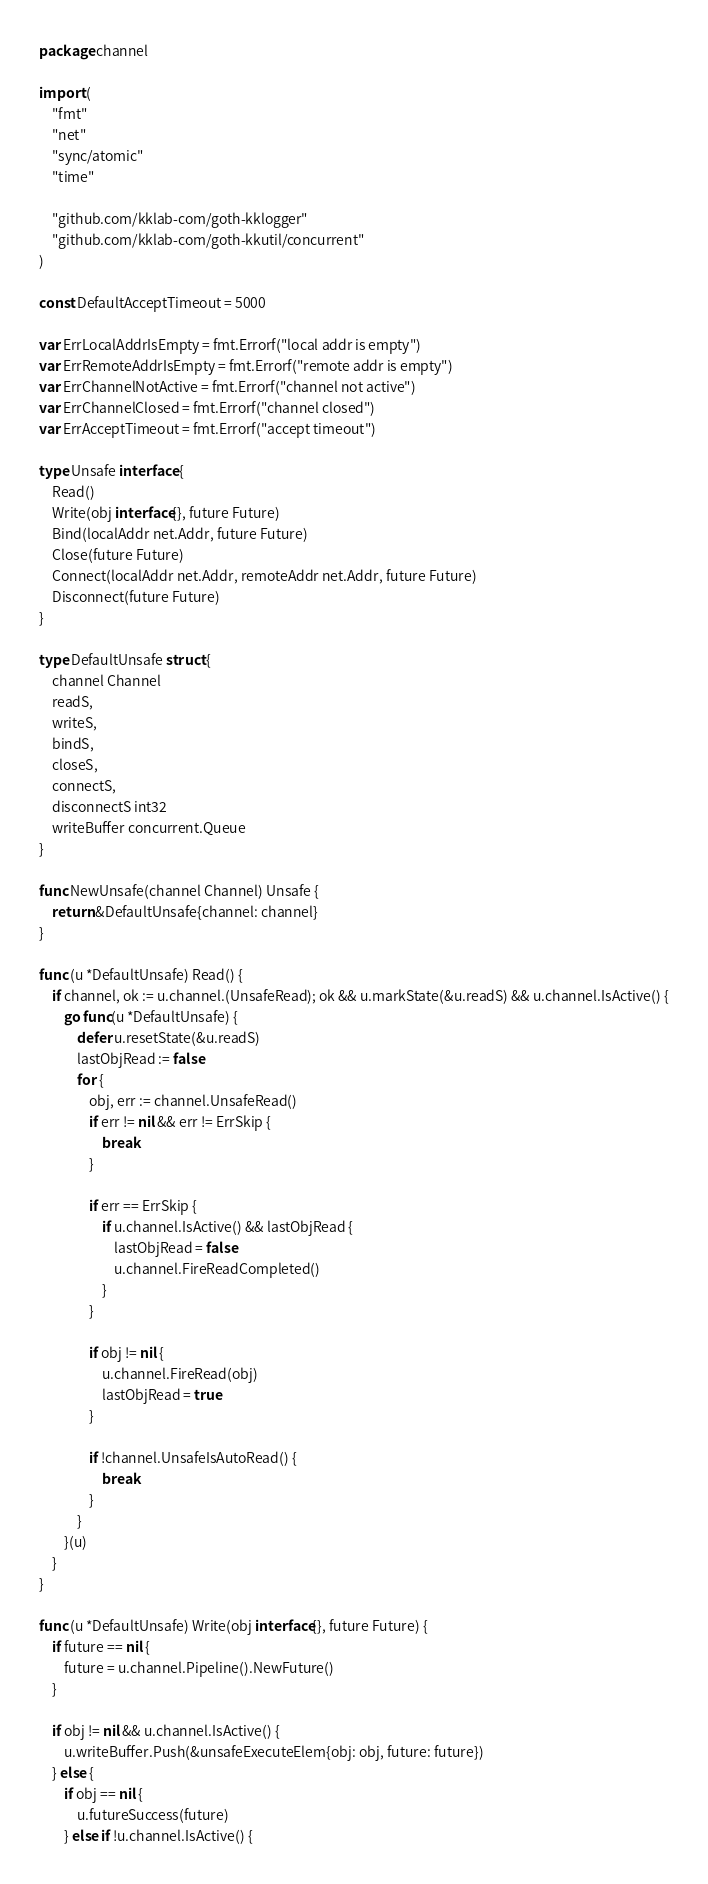<code> <loc_0><loc_0><loc_500><loc_500><_Go_>package channel

import (
	"fmt"
	"net"
	"sync/atomic"
	"time"

	"github.com/kklab-com/goth-kklogger"
	"github.com/kklab-com/goth-kkutil/concurrent"
)

const DefaultAcceptTimeout = 5000

var ErrLocalAddrIsEmpty = fmt.Errorf("local addr is empty")
var ErrRemoteAddrIsEmpty = fmt.Errorf("remote addr is empty")
var ErrChannelNotActive = fmt.Errorf("channel not active")
var ErrChannelClosed = fmt.Errorf("channel closed")
var ErrAcceptTimeout = fmt.Errorf("accept timeout")

type Unsafe interface {
	Read()
	Write(obj interface{}, future Future)
	Bind(localAddr net.Addr, future Future)
	Close(future Future)
	Connect(localAddr net.Addr, remoteAddr net.Addr, future Future)
	Disconnect(future Future)
}

type DefaultUnsafe struct {
	channel Channel
	readS,
	writeS,
	bindS,
	closeS,
	connectS,
	disconnectS int32
	writeBuffer concurrent.Queue
}

func NewUnsafe(channel Channel) Unsafe {
	return &DefaultUnsafe{channel: channel}
}

func (u *DefaultUnsafe) Read() {
	if channel, ok := u.channel.(UnsafeRead); ok && u.markState(&u.readS) && u.channel.IsActive() {
		go func(u *DefaultUnsafe) {
			defer u.resetState(&u.readS)
			lastObjRead := false
			for {
				obj, err := channel.UnsafeRead()
				if err != nil && err != ErrSkip {
					break
				}

				if err == ErrSkip {
					if u.channel.IsActive() && lastObjRead {
						lastObjRead = false
						u.channel.FireReadCompleted()
					}
				}

				if obj != nil {
					u.channel.FireRead(obj)
					lastObjRead = true
				}

				if !channel.UnsafeIsAutoRead() {
					break
				}
			}
		}(u)
	}
}

func (u *DefaultUnsafe) Write(obj interface{}, future Future) {
	if future == nil {
		future = u.channel.Pipeline().NewFuture()
	}

	if obj != nil && u.channel.IsActive() {
		u.writeBuffer.Push(&unsafeExecuteElem{obj: obj, future: future})
	} else {
		if obj == nil {
			u.futureSuccess(future)
		} else if !u.channel.IsActive() {</code> 